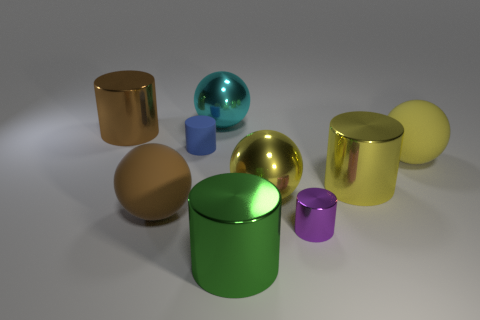Is there a pattern to how the objects are arranged? There doesn't seem to be a clear pattern to the arrangement of the objects. They are placed randomly with respect to size, color, and type. This random placement can draw the viewer's attention to the individual shapes and textures of each object. 